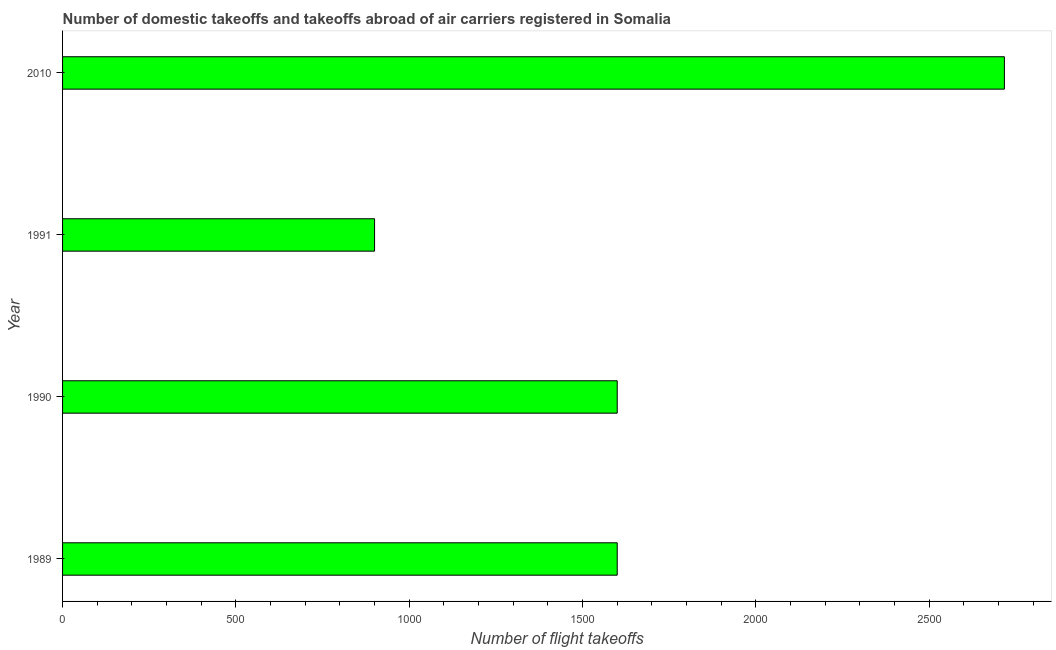Does the graph contain any zero values?
Offer a terse response. No. What is the title of the graph?
Make the answer very short. Number of domestic takeoffs and takeoffs abroad of air carriers registered in Somalia. What is the label or title of the X-axis?
Keep it short and to the point. Number of flight takeoffs. What is the number of flight takeoffs in 1990?
Your answer should be very brief. 1600. Across all years, what is the maximum number of flight takeoffs?
Make the answer very short. 2716.91. Across all years, what is the minimum number of flight takeoffs?
Your answer should be very brief. 900. What is the sum of the number of flight takeoffs?
Your response must be concise. 6816.91. What is the difference between the number of flight takeoffs in 1989 and 1990?
Offer a terse response. 0. What is the average number of flight takeoffs per year?
Give a very brief answer. 1704.23. What is the median number of flight takeoffs?
Offer a terse response. 1600. In how many years, is the number of flight takeoffs greater than 1400 ?
Offer a terse response. 3. What is the ratio of the number of flight takeoffs in 1991 to that in 2010?
Make the answer very short. 0.33. Is the number of flight takeoffs in 1990 less than that in 1991?
Keep it short and to the point. No. What is the difference between the highest and the second highest number of flight takeoffs?
Keep it short and to the point. 1116.91. What is the difference between the highest and the lowest number of flight takeoffs?
Offer a very short reply. 1816.91. In how many years, is the number of flight takeoffs greater than the average number of flight takeoffs taken over all years?
Offer a terse response. 1. Are the values on the major ticks of X-axis written in scientific E-notation?
Offer a terse response. No. What is the Number of flight takeoffs in 1989?
Your response must be concise. 1600. What is the Number of flight takeoffs of 1990?
Your answer should be compact. 1600. What is the Number of flight takeoffs in 1991?
Your answer should be compact. 900. What is the Number of flight takeoffs in 2010?
Your response must be concise. 2716.91. What is the difference between the Number of flight takeoffs in 1989 and 1990?
Your answer should be compact. 0. What is the difference between the Number of flight takeoffs in 1989 and 1991?
Ensure brevity in your answer.  700. What is the difference between the Number of flight takeoffs in 1989 and 2010?
Your answer should be very brief. -1116.91. What is the difference between the Number of flight takeoffs in 1990 and 1991?
Keep it short and to the point. 700. What is the difference between the Number of flight takeoffs in 1990 and 2010?
Offer a terse response. -1116.91. What is the difference between the Number of flight takeoffs in 1991 and 2010?
Make the answer very short. -1816.91. What is the ratio of the Number of flight takeoffs in 1989 to that in 1991?
Offer a terse response. 1.78. What is the ratio of the Number of flight takeoffs in 1989 to that in 2010?
Your answer should be very brief. 0.59. What is the ratio of the Number of flight takeoffs in 1990 to that in 1991?
Provide a succinct answer. 1.78. What is the ratio of the Number of flight takeoffs in 1990 to that in 2010?
Ensure brevity in your answer.  0.59. What is the ratio of the Number of flight takeoffs in 1991 to that in 2010?
Ensure brevity in your answer.  0.33. 